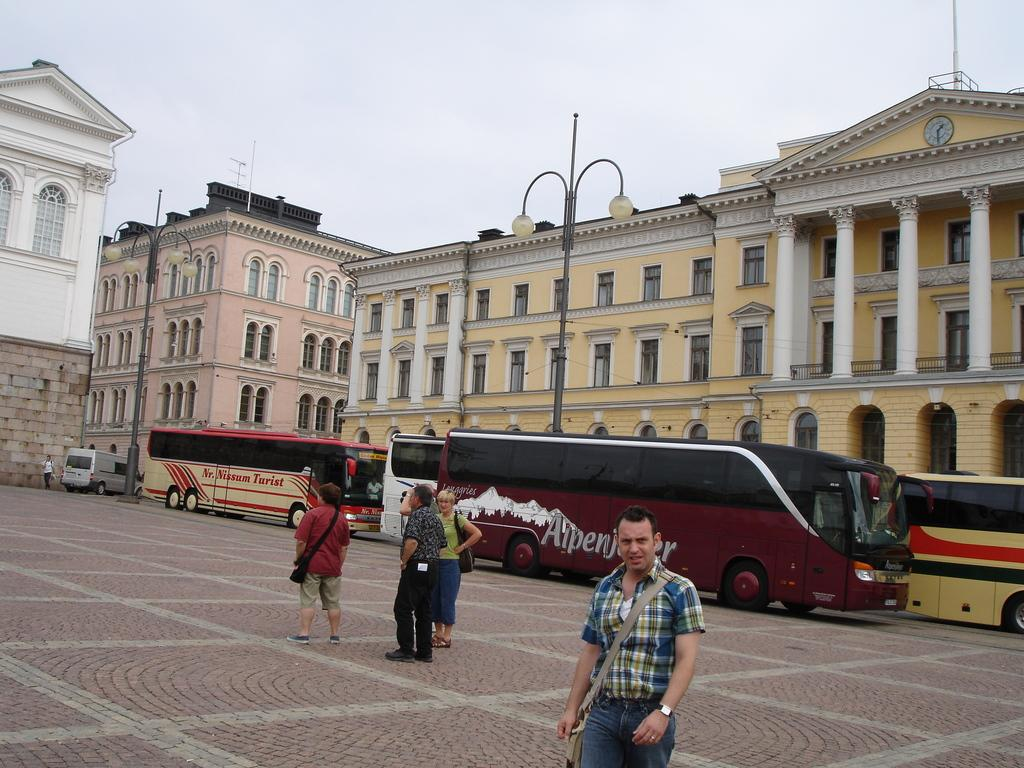What is the main subject in the center of the image? There are buses in the center of the image. What else can be seen on the road in the image? There are people on the road. What can be seen in the background of the image? There are lights and buildings in the background. What is visible at the top of the image? The sky is visible at the top of the image. What type of fuel is being used by the tongue in the image? There is no tongue present in the image, and therefore no fuel can be associated with it. 